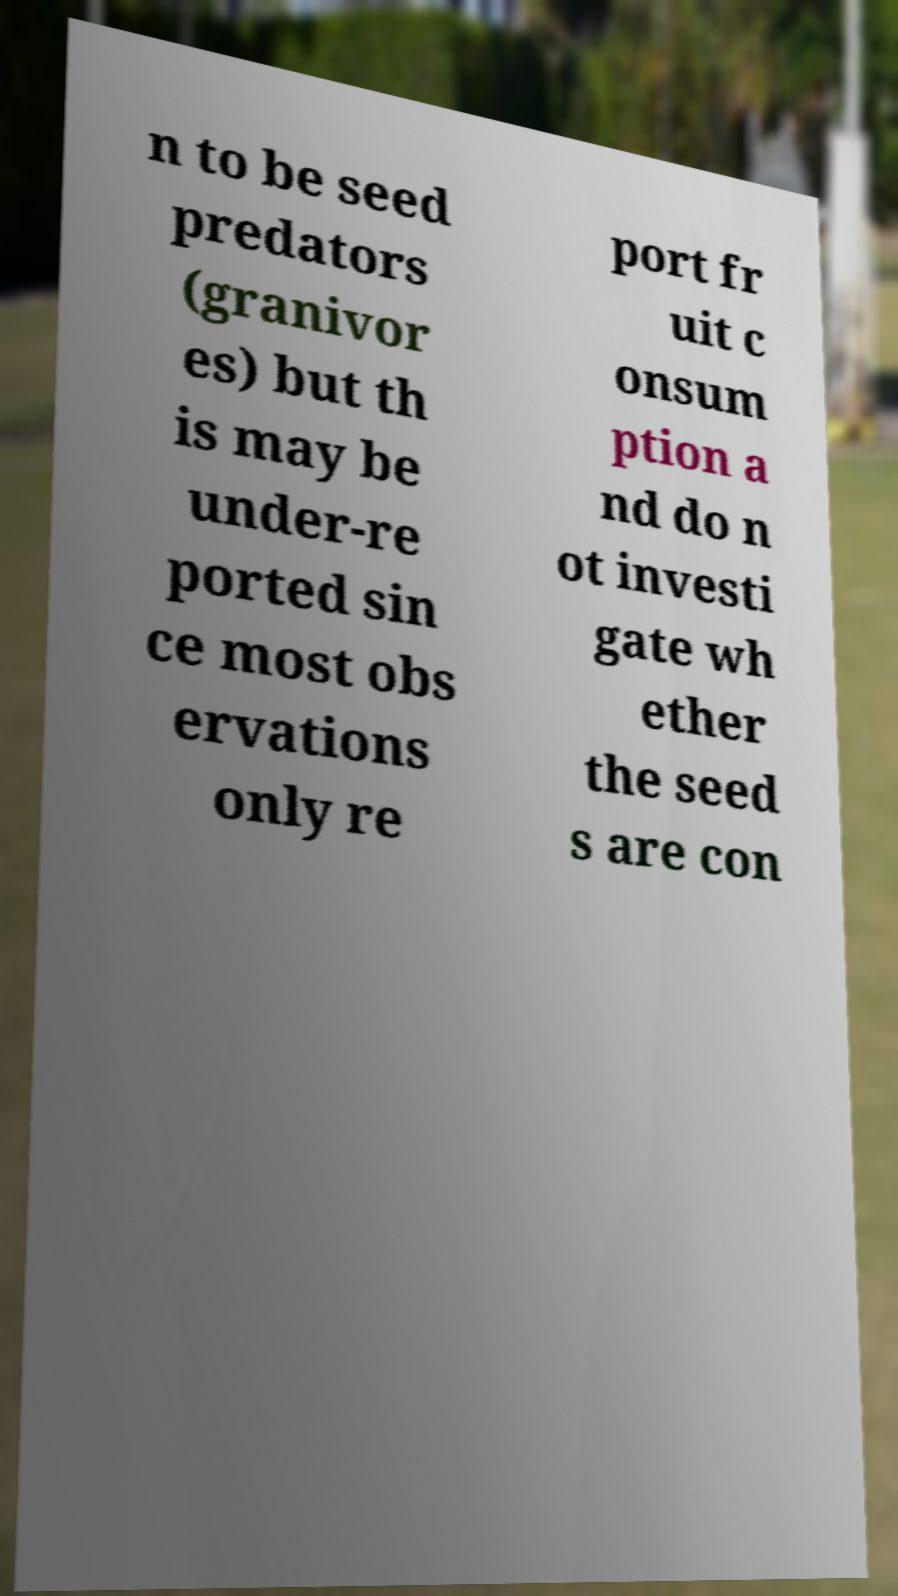Could you extract and type out the text from this image? n to be seed predators (granivor es) but th is may be under-re ported sin ce most obs ervations only re port fr uit c onsum ption a nd do n ot investi gate wh ether the seed s are con 